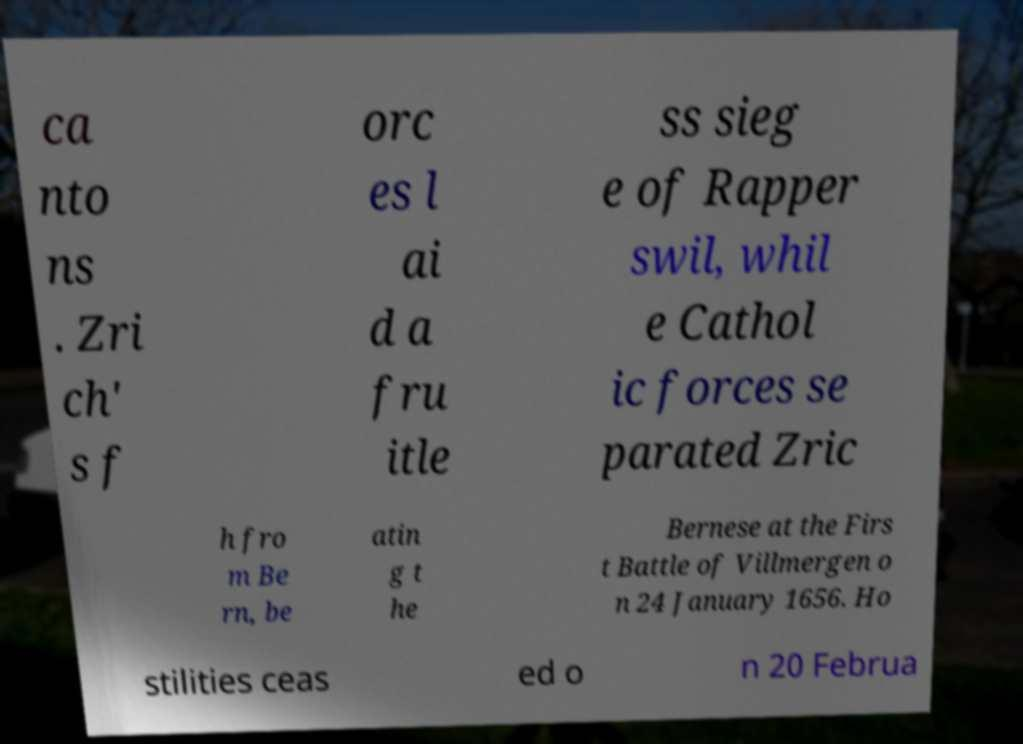What messages or text are displayed in this image? I need them in a readable, typed format. ca nto ns . Zri ch' s f orc es l ai d a fru itle ss sieg e of Rapper swil, whil e Cathol ic forces se parated Zric h fro m Be rn, be atin g t he Bernese at the Firs t Battle of Villmergen o n 24 January 1656. Ho stilities ceas ed o n 20 Februa 